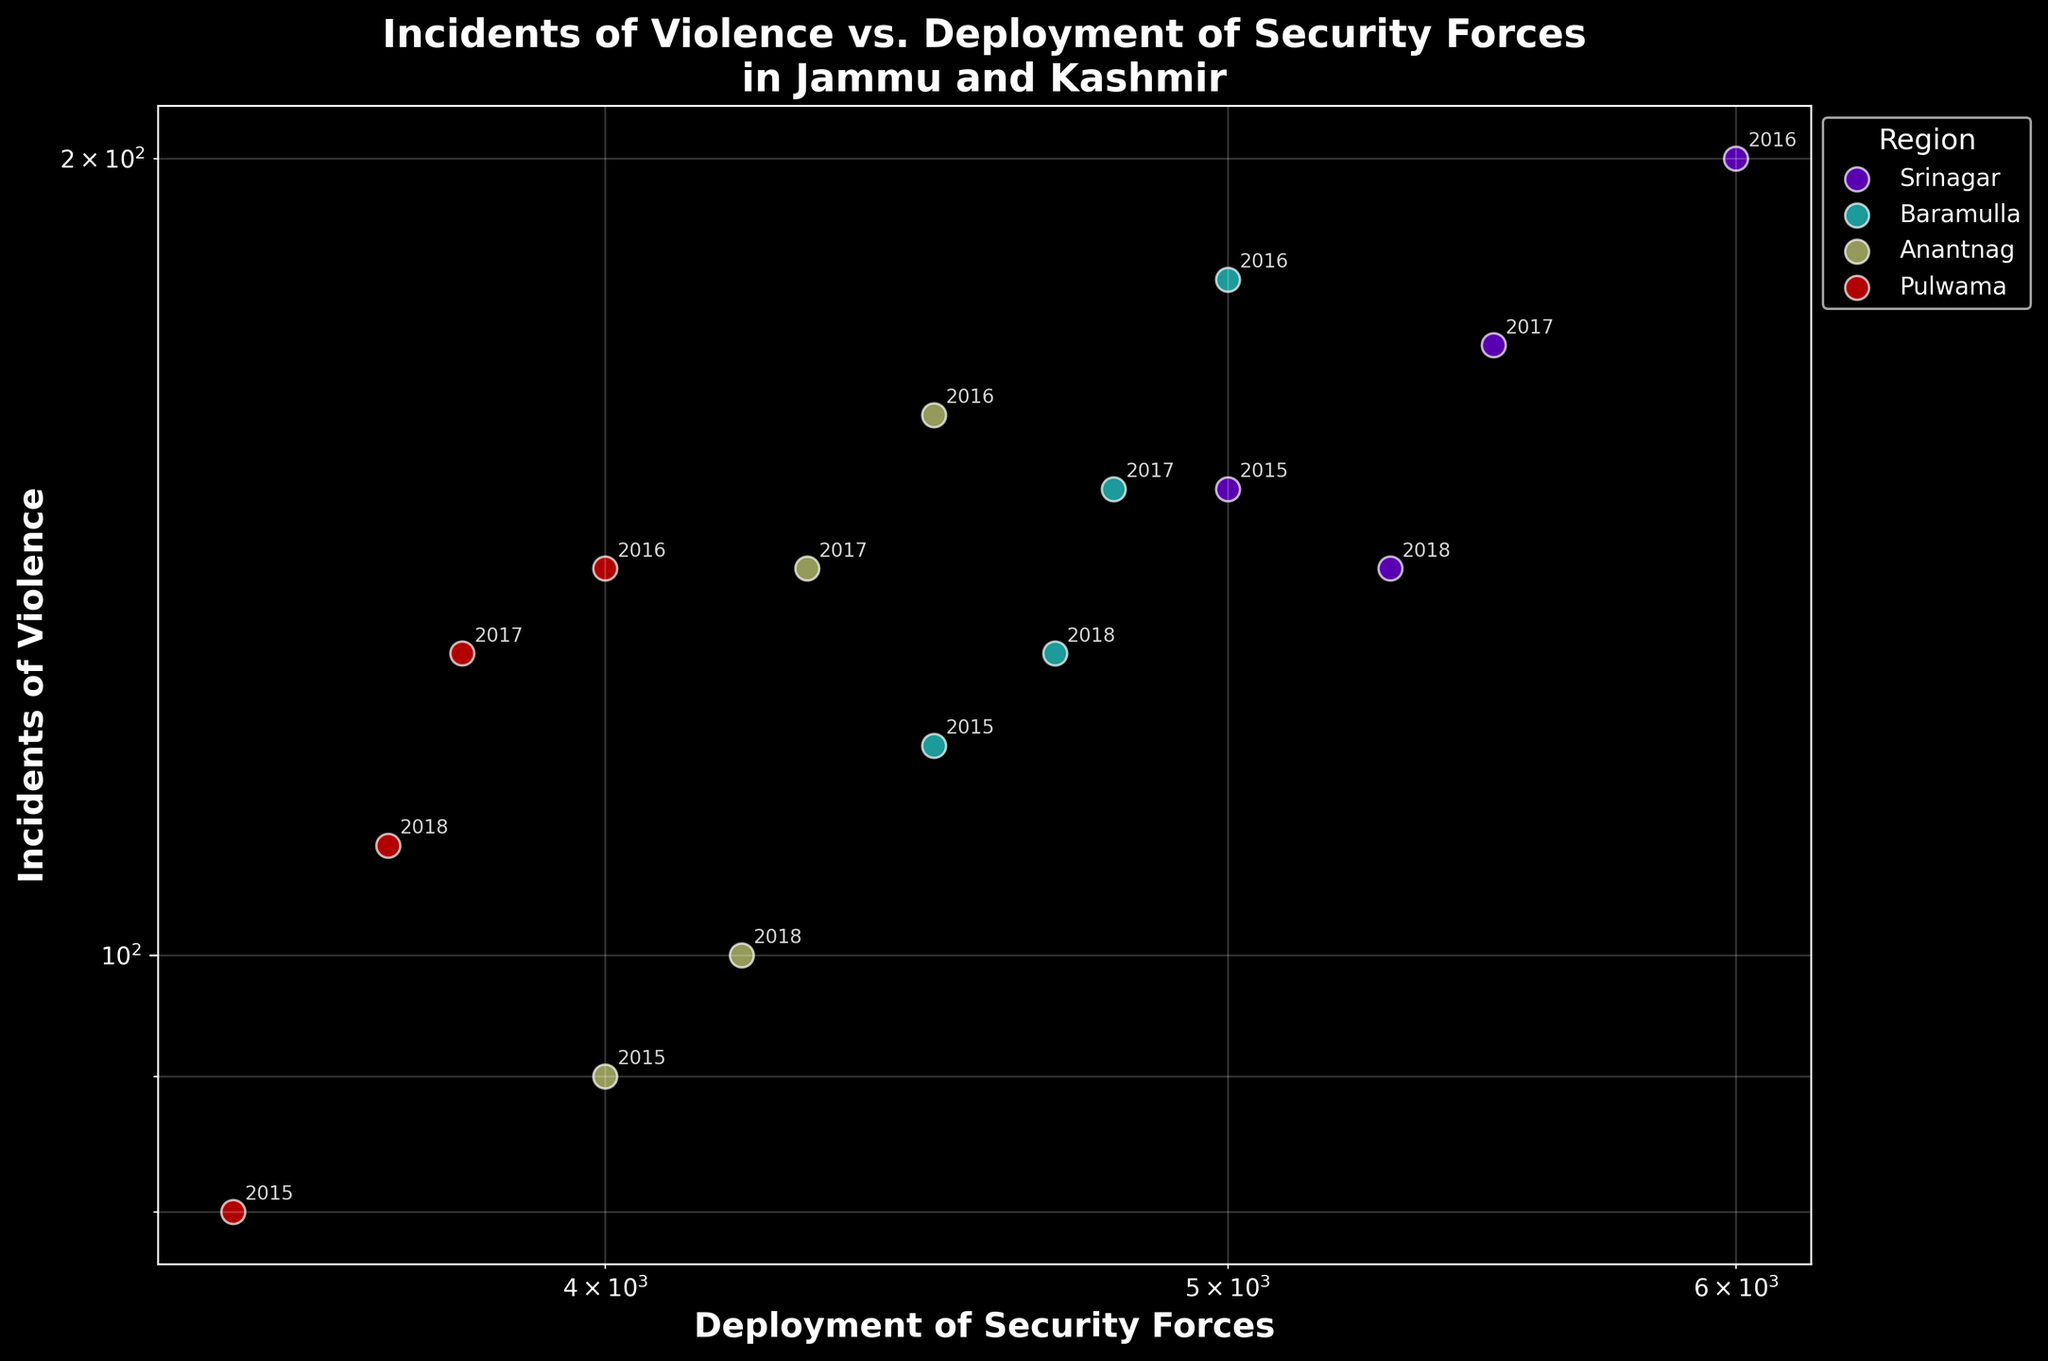How many regions are shown in the plot? The figure includes one scatter plot with different colors for each region. Each unique color represents a distinct region. Count the number of unique colors or labels indicated in the legend.
Answer: 4 What is the title of the figure? The title is prominently displayed at the top of the plot, summarizing what the scatter plot is about.
Answer: Incidents of Violence vs. Deployment of Security Forces in Jammu and Kashmir Which region had the highest number of incidents of violence in 2016? Locate the year 2016 annotations for each region and compare the respective incidents of violence values. The highest number among them indicates the region.
Answer: Srinagar What's the general trend between the deployment of security forces and incidents of violence in the regions? Observe the scatter points. A general trend in the plot with axes on log scale often shows whether the relationship is positive, negative, or neutral.
Answer: Positive correlation Which region shows the least deployment of security forces but still has significant incidents of violence? Identify the region with the lowest values on the x-axis but noticeable values on the y-axis. Compare these values across different regions.
Answer: Pulwama Is there any region where the incidents of violence decreased steadily from 2015 to 2018? Trace the annotations for each region from 2015 to 2018, checking if incidents of violence (y-axis values) decreased each year.
Answer: Srinagar Among all the regions, which one had the lowest incidents of violence in 2018? Look for the 2018 annotations across all regions and compare their incidents of violence values to find the smallest number.
Answer: Anantnag Which region had a consistent level of deployment of security forces over the years? Observe the annotated data points for each region over different years, checking if the deployment of security forces (x-axis values) remained roughly at the same level.
Answer: Baramulla Considering the years 2016 and 2017, in which region did the incidents of violence show the most significant decrease? Compare the decrease in incidents of violence between 2016 and 2017 for each region by looking at the difference in y-axis values.
Answer: Baramulla 